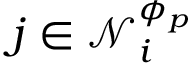<formula> <loc_0><loc_0><loc_500><loc_500>j \in \mathcal { N } _ { i } ^ { \phi _ { p } }</formula> 